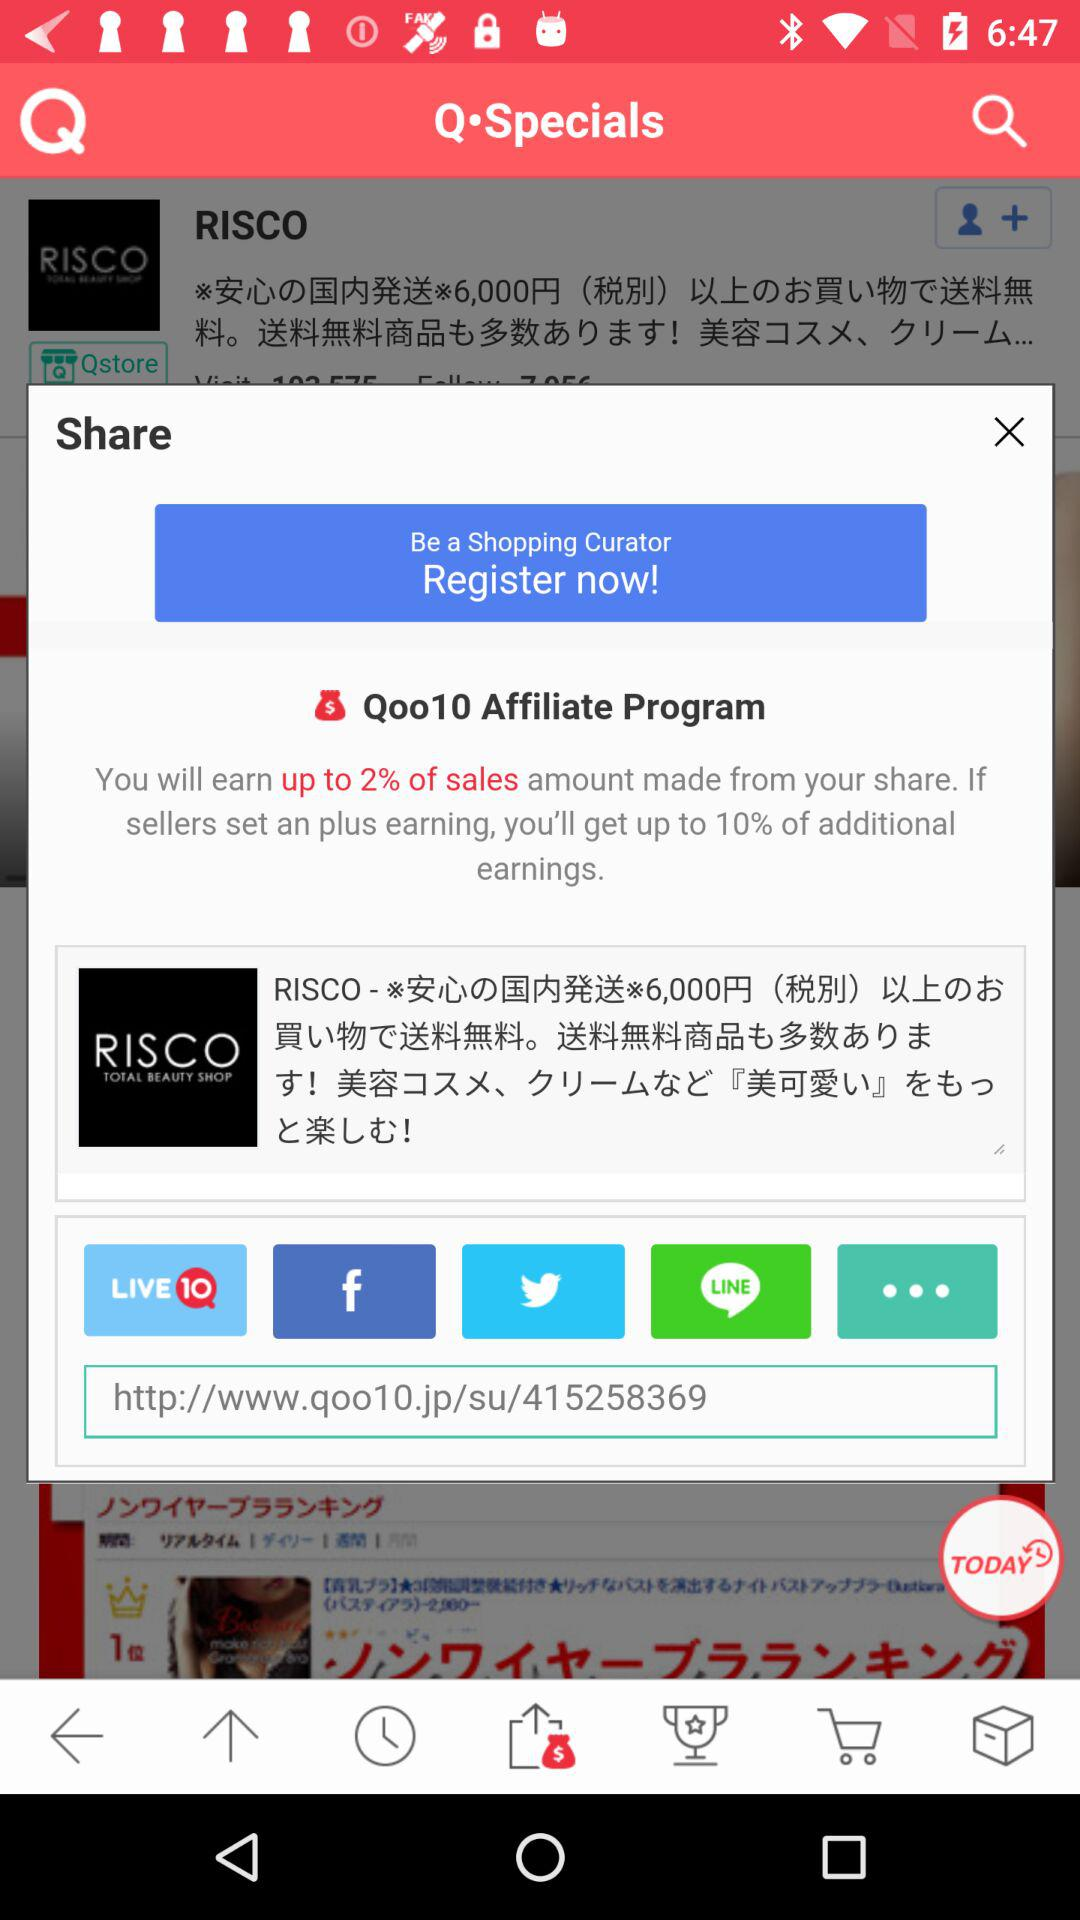What is the percentage we can earn from the share? You can earn up to 2% of the sales amount from the share. 